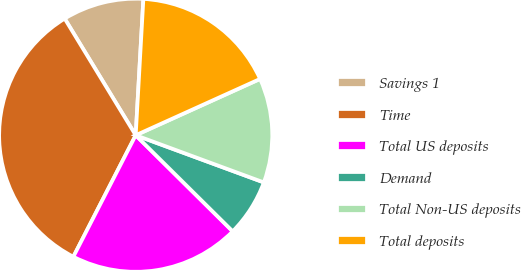<chart> <loc_0><loc_0><loc_500><loc_500><pie_chart><fcel>Savings 1<fcel>Time<fcel>Total US deposits<fcel>Demand<fcel>Total Non-US deposits<fcel>Total deposits<nl><fcel>9.6%<fcel>33.75%<fcel>20.12%<fcel>6.81%<fcel>12.38%<fcel>17.34%<nl></chart> 